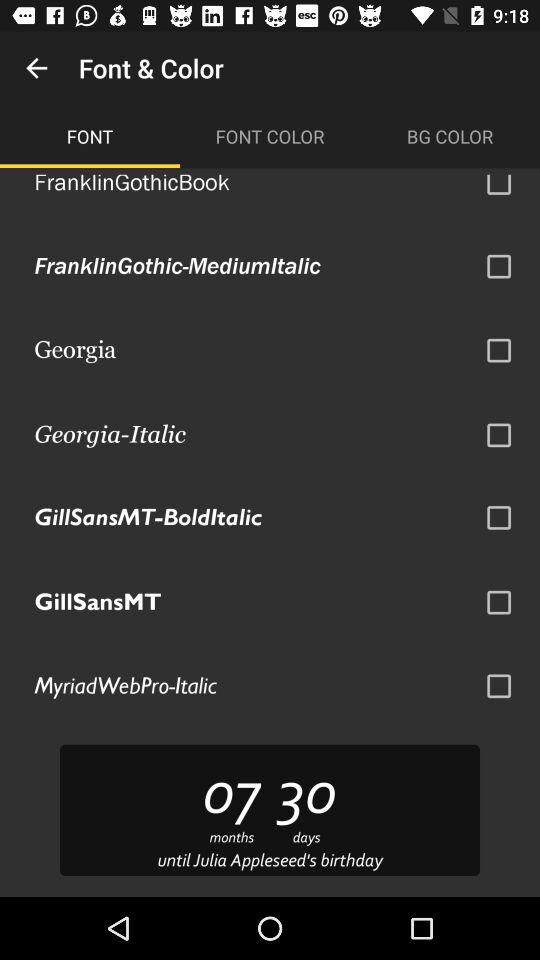What is the selected font color?
When the provided information is insufficient, respond with <no answer>. <no answer> 